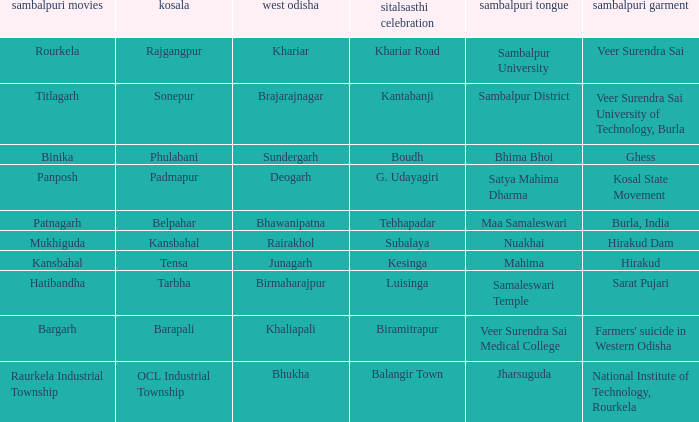What is the sitalsasthi carnival with sonepur as kosal? Kantabanji. 